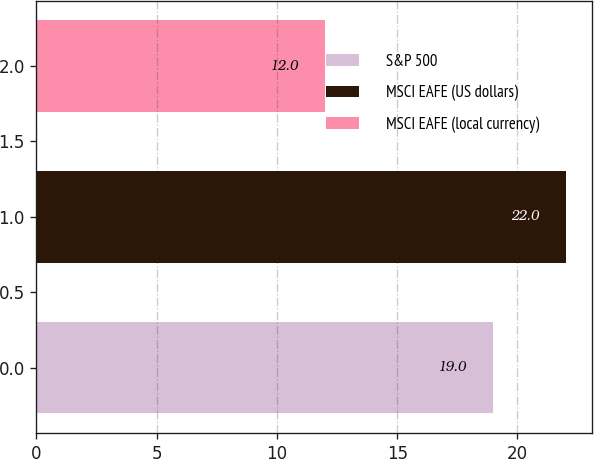<chart> <loc_0><loc_0><loc_500><loc_500><bar_chart><fcel>S&P 500<fcel>MSCI EAFE (US dollars)<fcel>MSCI EAFE (local currency)<nl><fcel>19<fcel>22<fcel>12<nl></chart> 